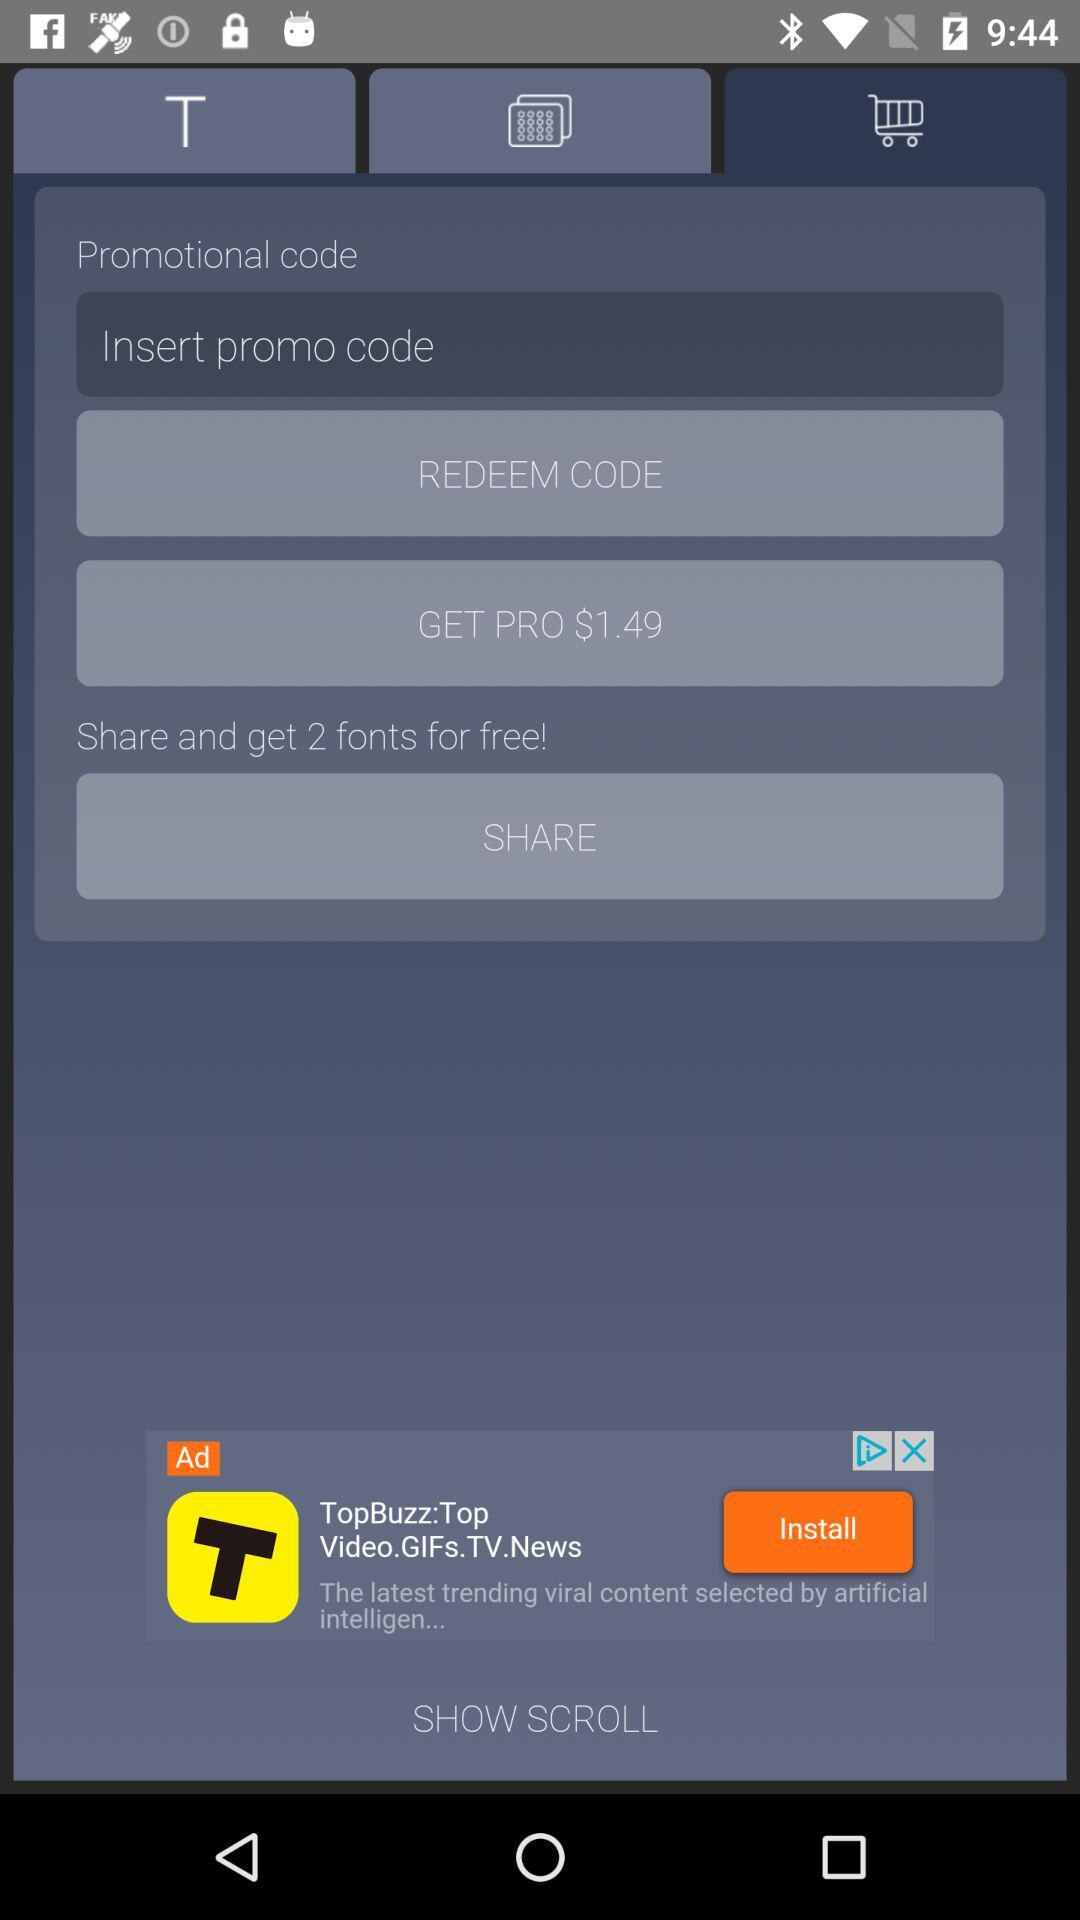How much dollar is needed to get a pro? To get a pro, $1.49 is needed. 